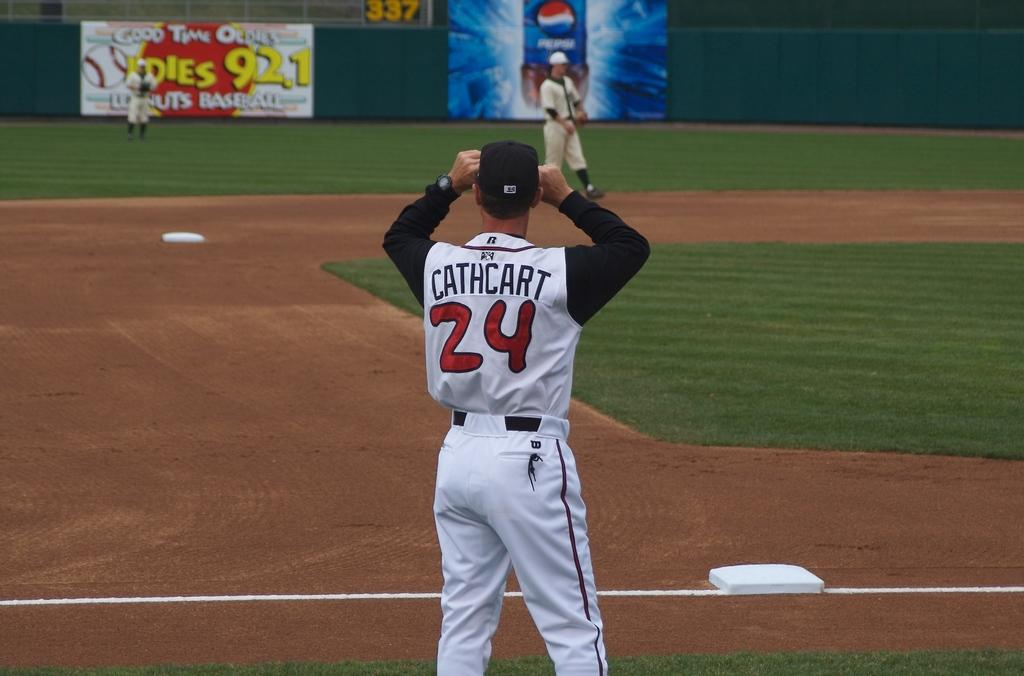<image>
Create a compact narrative representing the image presented. Baseball player wearing number 24 looking into the field. 